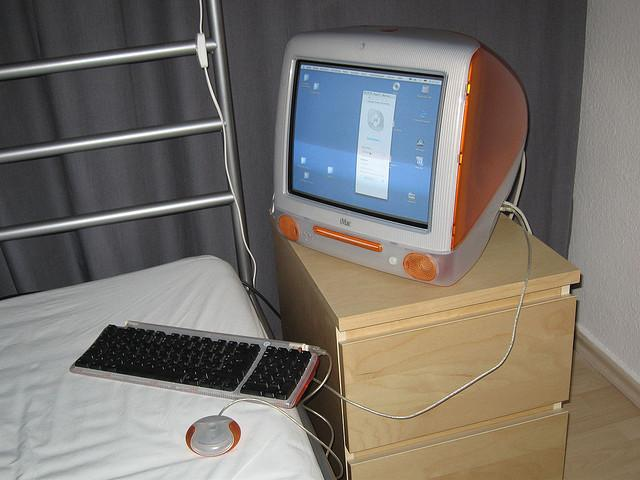What is sitting on the dresser? monitor 